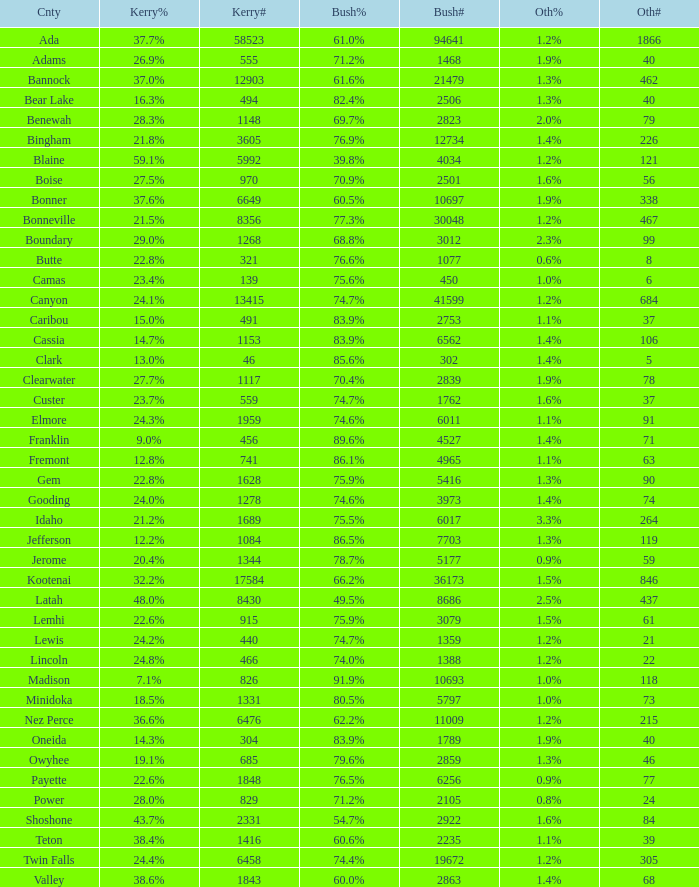What percentage of the people in Bonneville voted for Bush? 77.3%. 